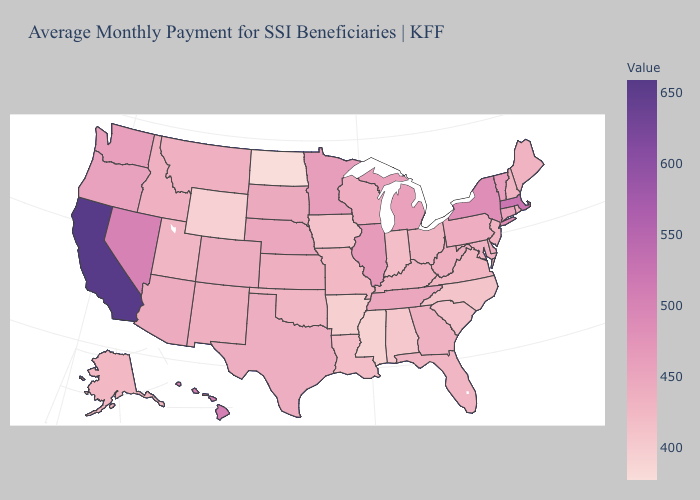Does Louisiana have a higher value than Connecticut?
Give a very brief answer. No. Among the states that border Wisconsin , which have the lowest value?
Quick response, please. Iowa. Which states have the highest value in the USA?
Keep it brief. California. Does Mississippi have the lowest value in the USA?
Concise answer only. No. 